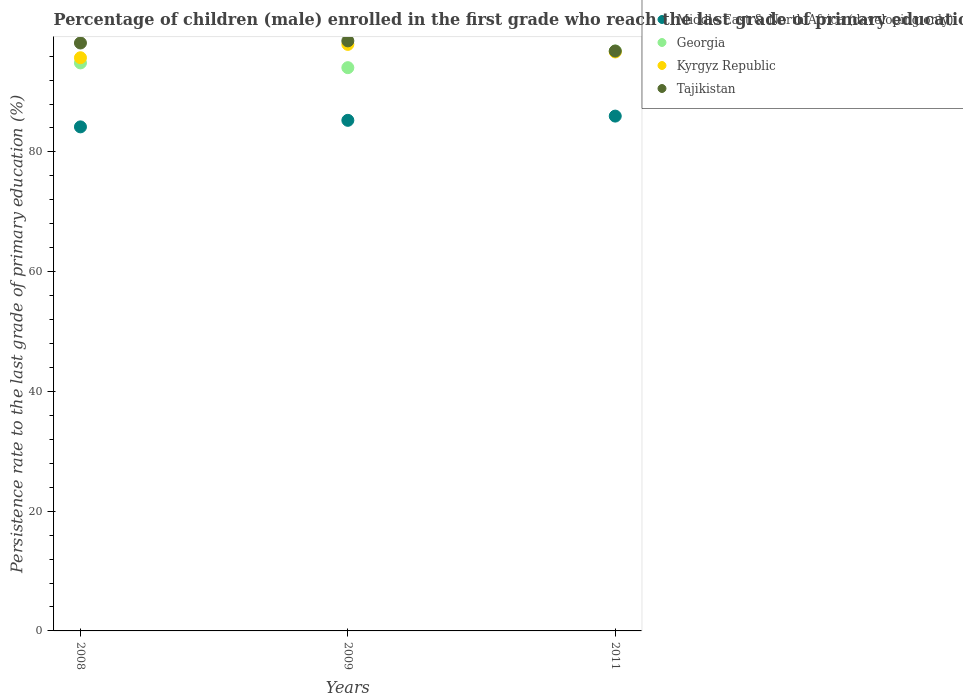How many different coloured dotlines are there?
Make the answer very short. 4. What is the persistence rate of children in Middle East & North Africa (developing only) in 2009?
Your response must be concise. 85.28. Across all years, what is the maximum persistence rate of children in Tajikistan?
Your answer should be very brief. 98.55. Across all years, what is the minimum persistence rate of children in Georgia?
Provide a short and direct response. 94.08. In which year was the persistence rate of children in Tajikistan maximum?
Your answer should be compact. 2009. What is the total persistence rate of children in Tajikistan in the graph?
Keep it short and to the point. 293.6. What is the difference between the persistence rate of children in Georgia in 2008 and that in 2011?
Your answer should be compact. -1.99. What is the difference between the persistence rate of children in Middle East & North Africa (developing only) in 2011 and the persistence rate of children in Georgia in 2009?
Keep it short and to the point. -8.09. What is the average persistence rate of children in Tajikistan per year?
Provide a short and direct response. 97.87. In the year 2011, what is the difference between the persistence rate of children in Georgia and persistence rate of children in Middle East & North Africa (developing only)?
Ensure brevity in your answer.  10.87. What is the ratio of the persistence rate of children in Georgia in 2008 to that in 2011?
Your response must be concise. 0.98. Is the persistence rate of children in Tajikistan in 2009 less than that in 2011?
Give a very brief answer. No. What is the difference between the highest and the second highest persistence rate of children in Tajikistan?
Keep it short and to the point. 0.35. What is the difference between the highest and the lowest persistence rate of children in Tajikistan?
Offer a terse response. 1.7. In how many years, is the persistence rate of children in Middle East & North Africa (developing only) greater than the average persistence rate of children in Middle East & North Africa (developing only) taken over all years?
Your answer should be compact. 2. Is the persistence rate of children in Georgia strictly greater than the persistence rate of children in Kyrgyz Republic over the years?
Make the answer very short. No. Are the values on the major ticks of Y-axis written in scientific E-notation?
Offer a very short reply. No. What is the title of the graph?
Provide a short and direct response. Percentage of children (male) enrolled in the first grade who reach the last grade of primary education. Does "Egypt, Arab Rep." appear as one of the legend labels in the graph?
Offer a terse response. No. What is the label or title of the Y-axis?
Provide a succinct answer. Persistence rate to the last grade of primary education (%). What is the Persistence rate to the last grade of primary education (%) of Middle East & North Africa (developing only) in 2008?
Give a very brief answer. 84.19. What is the Persistence rate to the last grade of primary education (%) of Georgia in 2008?
Your answer should be very brief. 94.87. What is the Persistence rate to the last grade of primary education (%) in Kyrgyz Republic in 2008?
Ensure brevity in your answer.  95.74. What is the Persistence rate to the last grade of primary education (%) of Tajikistan in 2008?
Provide a succinct answer. 98.2. What is the Persistence rate to the last grade of primary education (%) of Middle East & North Africa (developing only) in 2009?
Give a very brief answer. 85.28. What is the Persistence rate to the last grade of primary education (%) of Georgia in 2009?
Provide a short and direct response. 94.08. What is the Persistence rate to the last grade of primary education (%) of Kyrgyz Republic in 2009?
Give a very brief answer. 97.96. What is the Persistence rate to the last grade of primary education (%) in Tajikistan in 2009?
Your answer should be compact. 98.55. What is the Persistence rate to the last grade of primary education (%) of Middle East & North Africa (developing only) in 2011?
Provide a short and direct response. 85.99. What is the Persistence rate to the last grade of primary education (%) of Georgia in 2011?
Offer a terse response. 96.86. What is the Persistence rate to the last grade of primary education (%) in Kyrgyz Republic in 2011?
Your answer should be very brief. 96.7. What is the Persistence rate to the last grade of primary education (%) in Tajikistan in 2011?
Make the answer very short. 96.85. Across all years, what is the maximum Persistence rate to the last grade of primary education (%) in Middle East & North Africa (developing only)?
Ensure brevity in your answer.  85.99. Across all years, what is the maximum Persistence rate to the last grade of primary education (%) in Georgia?
Offer a terse response. 96.86. Across all years, what is the maximum Persistence rate to the last grade of primary education (%) of Kyrgyz Republic?
Provide a short and direct response. 97.96. Across all years, what is the maximum Persistence rate to the last grade of primary education (%) of Tajikistan?
Your answer should be compact. 98.55. Across all years, what is the minimum Persistence rate to the last grade of primary education (%) of Middle East & North Africa (developing only)?
Offer a very short reply. 84.19. Across all years, what is the minimum Persistence rate to the last grade of primary education (%) in Georgia?
Give a very brief answer. 94.08. Across all years, what is the minimum Persistence rate to the last grade of primary education (%) in Kyrgyz Republic?
Your answer should be very brief. 95.74. Across all years, what is the minimum Persistence rate to the last grade of primary education (%) in Tajikistan?
Offer a very short reply. 96.85. What is the total Persistence rate to the last grade of primary education (%) in Middle East & North Africa (developing only) in the graph?
Your answer should be compact. 255.45. What is the total Persistence rate to the last grade of primary education (%) of Georgia in the graph?
Keep it short and to the point. 285.8. What is the total Persistence rate to the last grade of primary education (%) in Kyrgyz Republic in the graph?
Provide a short and direct response. 290.4. What is the total Persistence rate to the last grade of primary education (%) of Tajikistan in the graph?
Your answer should be compact. 293.6. What is the difference between the Persistence rate to the last grade of primary education (%) in Middle East & North Africa (developing only) in 2008 and that in 2009?
Provide a short and direct response. -1.09. What is the difference between the Persistence rate to the last grade of primary education (%) in Georgia in 2008 and that in 2009?
Provide a short and direct response. 0.79. What is the difference between the Persistence rate to the last grade of primary education (%) of Kyrgyz Republic in 2008 and that in 2009?
Offer a terse response. -2.23. What is the difference between the Persistence rate to the last grade of primary education (%) in Tajikistan in 2008 and that in 2009?
Offer a terse response. -0.35. What is the difference between the Persistence rate to the last grade of primary education (%) in Middle East & North Africa (developing only) in 2008 and that in 2011?
Your response must be concise. -1.8. What is the difference between the Persistence rate to the last grade of primary education (%) of Georgia in 2008 and that in 2011?
Offer a terse response. -1.99. What is the difference between the Persistence rate to the last grade of primary education (%) of Kyrgyz Republic in 2008 and that in 2011?
Provide a succinct answer. -0.96. What is the difference between the Persistence rate to the last grade of primary education (%) of Tajikistan in 2008 and that in 2011?
Keep it short and to the point. 1.34. What is the difference between the Persistence rate to the last grade of primary education (%) of Middle East & North Africa (developing only) in 2009 and that in 2011?
Your answer should be very brief. -0.71. What is the difference between the Persistence rate to the last grade of primary education (%) of Georgia in 2009 and that in 2011?
Provide a succinct answer. -2.78. What is the difference between the Persistence rate to the last grade of primary education (%) in Kyrgyz Republic in 2009 and that in 2011?
Your answer should be compact. 1.27. What is the difference between the Persistence rate to the last grade of primary education (%) in Tajikistan in 2009 and that in 2011?
Your response must be concise. 1.7. What is the difference between the Persistence rate to the last grade of primary education (%) in Middle East & North Africa (developing only) in 2008 and the Persistence rate to the last grade of primary education (%) in Georgia in 2009?
Your answer should be very brief. -9.89. What is the difference between the Persistence rate to the last grade of primary education (%) of Middle East & North Africa (developing only) in 2008 and the Persistence rate to the last grade of primary education (%) of Kyrgyz Republic in 2009?
Provide a succinct answer. -13.78. What is the difference between the Persistence rate to the last grade of primary education (%) in Middle East & North Africa (developing only) in 2008 and the Persistence rate to the last grade of primary education (%) in Tajikistan in 2009?
Provide a succinct answer. -14.36. What is the difference between the Persistence rate to the last grade of primary education (%) of Georgia in 2008 and the Persistence rate to the last grade of primary education (%) of Kyrgyz Republic in 2009?
Your answer should be very brief. -3.09. What is the difference between the Persistence rate to the last grade of primary education (%) of Georgia in 2008 and the Persistence rate to the last grade of primary education (%) of Tajikistan in 2009?
Your answer should be very brief. -3.68. What is the difference between the Persistence rate to the last grade of primary education (%) of Kyrgyz Republic in 2008 and the Persistence rate to the last grade of primary education (%) of Tajikistan in 2009?
Provide a succinct answer. -2.82. What is the difference between the Persistence rate to the last grade of primary education (%) of Middle East & North Africa (developing only) in 2008 and the Persistence rate to the last grade of primary education (%) of Georgia in 2011?
Keep it short and to the point. -12.67. What is the difference between the Persistence rate to the last grade of primary education (%) in Middle East & North Africa (developing only) in 2008 and the Persistence rate to the last grade of primary education (%) in Kyrgyz Republic in 2011?
Provide a short and direct response. -12.51. What is the difference between the Persistence rate to the last grade of primary education (%) of Middle East & North Africa (developing only) in 2008 and the Persistence rate to the last grade of primary education (%) of Tajikistan in 2011?
Offer a terse response. -12.67. What is the difference between the Persistence rate to the last grade of primary education (%) in Georgia in 2008 and the Persistence rate to the last grade of primary education (%) in Kyrgyz Republic in 2011?
Your response must be concise. -1.83. What is the difference between the Persistence rate to the last grade of primary education (%) in Georgia in 2008 and the Persistence rate to the last grade of primary education (%) in Tajikistan in 2011?
Give a very brief answer. -1.98. What is the difference between the Persistence rate to the last grade of primary education (%) in Kyrgyz Republic in 2008 and the Persistence rate to the last grade of primary education (%) in Tajikistan in 2011?
Your answer should be compact. -1.12. What is the difference between the Persistence rate to the last grade of primary education (%) of Middle East & North Africa (developing only) in 2009 and the Persistence rate to the last grade of primary education (%) of Georgia in 2011?
Provide a short and direct response. -11.58. What is the difference between the Persistence rate to the last grade of primary education (%) in Middle East & North Africa (developing only) in 2009 and the Persistence rate to the last grade of primary education (%) in Kyrgyz Republic in 2011?
Provide a succinct answer. -11.42. What is the difference between the Persistence rate to the last grade of primary education (%) of Middle East & North Africa (developing only) in 2009 and the Persistence rate to the last grade of primary education (%) of Tajikistan in 2011?
Your answer should be compact. -11.57. What is the difference between the Persistence rate to the last grade of primary education (%) of Georgia in 2009 and the Persistence rate to the last grade of primary education (%) of Kyrgyz Republic in 2011?
Ensure brevity in your answer.  -2.62. What is the difference between the Persistence rate to the last grade of primary education (%) of Georgia in 2009 and the Persistence rate to the last grade of primary education (%) of Tajikistan in 2011?
Offer a very short reply. -2.78. What is the difference between the Persistence rate to the last grade of primary education (%) of Kyrgyz Republic in 2009 and the Persistence rate to the last grade of primary education (%) of Tajikistan in 2011?
Your answer should be compact. 1.11. What is the average Persistence rate to the last grade of primary education (%) of Middle East & North Africa (developing only) per year?
Ensure brevity in your answer.  85.15. What is the average Persistence rate to the last grade of primary education (%) of Georgia per year?
Give a very brief answer. 95.27. What is the average Persistence rate to the last grade of primary education (%) in Kyrgyz Republic per year?
Your response must be concise. 96.8. What is the average Persistence rate to the last grade of primary education (%) of Tajikistan per year?
Your response must be concise. 97.87. In the year 2008, what is the difference between the Persistence rate to the last grade of primary education (%) of Middle East & North Africa (developing only) and Persistence rate to the last grade of primary education (%) of Georgia?
Make the answer very short. -10.68. In the year 2008, what is the difference between the Persistence rate to the last grade of primary education (%) of Middle East & North Africa (developing only) and Persistence rate to the last grade of primary education (%) of Kyrgyz Republic?
Provide a short and direct response. -11.55. In the year 2008, what is the difference between the Persistence rate to the last grade of primary education (%) of Middle East & North Africa (developing only) and Persistence rate to the last grade of primary education (%) of Tajikistan?
Provide a succinct answer. -14.01. In the year 2008, what is the difference between the Persistence rate to the last grade of primary education (%) in Georgia and Persistence rate to the last grade of primary education (%) in Kyrgyz Republic?
Keep it short and to the point. -0.86. In the year 2008, what is the difference between the Persistence rate to the last grade of primary education (%) in Georgia and Persistence rate to the last grade of primary education (%) in Tajikistan?
Your answer should be very brief. -3.33. In the year 2008, what is the difference between the Persistence rate to the last grade of primary education (%) in Kyrgyz Republic and Persistence rate to the last grade of primary education (%) in Tajikistan?
Keep it short and to the point. -2.46. In the year 2009, what is the difference between the Persistence rate to the last grade of primary education (%) in Middle East & North Africa (developing only) and Persistence rate to the last grade of primary education (%) in Georgia?
Make the answer very short. -8.8. In the year 2009, what is the difference between the Persistence rate to the last grade of primary education (%) of Middle East & North Africa (developing only) and Persistence rate to the last grade of primary education (%) of Kyrgyz Republic?
Offer a terse response. -12.68. In the year 2009, what is the difference between the Persistence rate to the last grade of primary education (%) in Middle East & North Africa (developing only) and Persistence rate to the last grade of primary education (%) in Tajikistan?
Give a very brief answer. -13.27. In the year 2009, what is the difference between the Persistence rate to the last grade of primary education (%) in Georgia and Persistence rate to the last grade of primary education (%) in Kyrgyz Republic?
Keep it short and to the point. -3.89. In the year 2009, what is the difference between the Persistence rate to the last grade of primary education (%) in Georgia and Persistence rate to the last grade of primary education (%) in Tajikistan?
Keep it short and to the point. -4.47. In the year 2009, what is the difference between the Persistence rate to the last grade of primary education (%) in Kyrgyz Republic and Persistence rate to the last grade of primary education (%) in Tajikistan?
Make the answer very short. -0.59. In the year 2011, what is the difference between the Persistence rate to the last grade of primary education (%) in Middle East & North Africa (developing only) and Persistence rate to the last grade of primary education (%) in Georgia?
Your response must be concise. -10.87. In the year 2011, what is the difference between the Persistence rate to the last grade of primary education (%) of Middle East & North Africa (developing only) and Persistence rate to the last grade of primary education (%) of Kyrgyz Republic?
Offer a terse response. -10.71. In the year 2011, what is the difference between the Persistence rate to the last grade of primary education (%) in Middle East & North Africa (developing only) and Persistence rate to the last grade of primary education (%) in Tajikistan?
Keep it short and to the point. -10.87. In the year 2011, what is the difference between the Persistence rate to the last grade of primary education (%) of Georgia and Persistence rate to the last grade of primary education (%) of Kyrgyz Republic?
Make the answer very short. 0.16. In the year 2011, what is the difference between the Persistence rate to the last grade of primary education (%) in Georgia and Persistence rate to the last grade of primary education (%) in Tajikistan?
Your answer should be very brief. 0. In the year 2011, what is the difference between the Persistence rate to the last grade of primary education (%) of Kyrgyz Republic and Persistence rate to the last grade of primary education (%) of Tajikistan?
Your answer should be very brief. -0.16. What is the ratio of the Persistence rate to the last grade of primary education (%) of Middle East & North Africa (developing only) in 2008 to that in 2009?
Provide a succinct answer. 0.99. What is the ratio of the Persistence rate to the last grade of primary education (%) of Georgia in 2008 to that in 2009?
Provide a succinct answer. 1.01. What is the ratio of the Persistence rate to the last grade of primary education (%) in Kyrgyz Republic in 2008 to that in 2009?
Ensure brevity in your answer.  0.98. What is the ratio of the Persistence rate to the last grade of primary education (%) in Middle East & North Africa (developing only) in 2008 to that in 2011?
Your answer should be compact. 0.98. What is the ratio of the Persistence rate to the last grade of primary education (%) of Georgia in 2008 to that in 2011?
Ensure brevity in your answer.  0.98. What is the ratio of the Persistence rate to the last grade of primary education (%) in Tajikistan in 2008 to that in 2011?
Offer a very short reply. 1.01. What is the ratio of the Persistence rate to the last grade of primary education (%) in Georgia in 2009 to that in 2011?
Offer a terse response. 0.97. What is the ratio of the Persistence rate to the last grade of primary education (%) of Kyrgyz Republic in 2009 to that in 2011?
Provide a short and direct response. 1.01. What is the ratio of the Persistence rate to the last grade of primary education (%) in Tajikistan in 2009 to that in 2011?
Your answer should be compact. 1.02. What is the difference between the highest and the second highest Persistence rate to the last grade of primary education (%) in Middle East & North Africa (developing only)?
Provide a succinct answer. 0.71. What is the difference between the highest and the second highest Persistence rate to the last grade of primary education (%) in Georgia?
Your response must be concise. 1.99. What is the difference between the highest and the second highest Persistence rate to the last grade of primary education (%) of Kyrgyz Republic?
Provide a succinct answer. 1.27. What is the difference between the highest and the second highest Persistence rate to the last grade of primary education (%) in Tajikistan?
Your response must be concise. 0.35. What is the difference between the highest and the lowest Persistence rate to the last grade of primary education (%) of Middle East & North Africa (developing only)?
Your answer should be compact. 1.8. What is the difference between the highest and the lowest Persistence rate to the last grade of primary education (%) in Georgia?
Your answer should be compact. 2.78. What is the difference between the highest and the lowest Persistence rate to the last grade of primary education (%) in Kyrgyz Republic?
Offer a terse response. 2.23. What is the difference between the highest and the lowest Persistence rate to the last grade of primary education (%) in Tajikistan?
Provide a succinct answer. 1.7. 